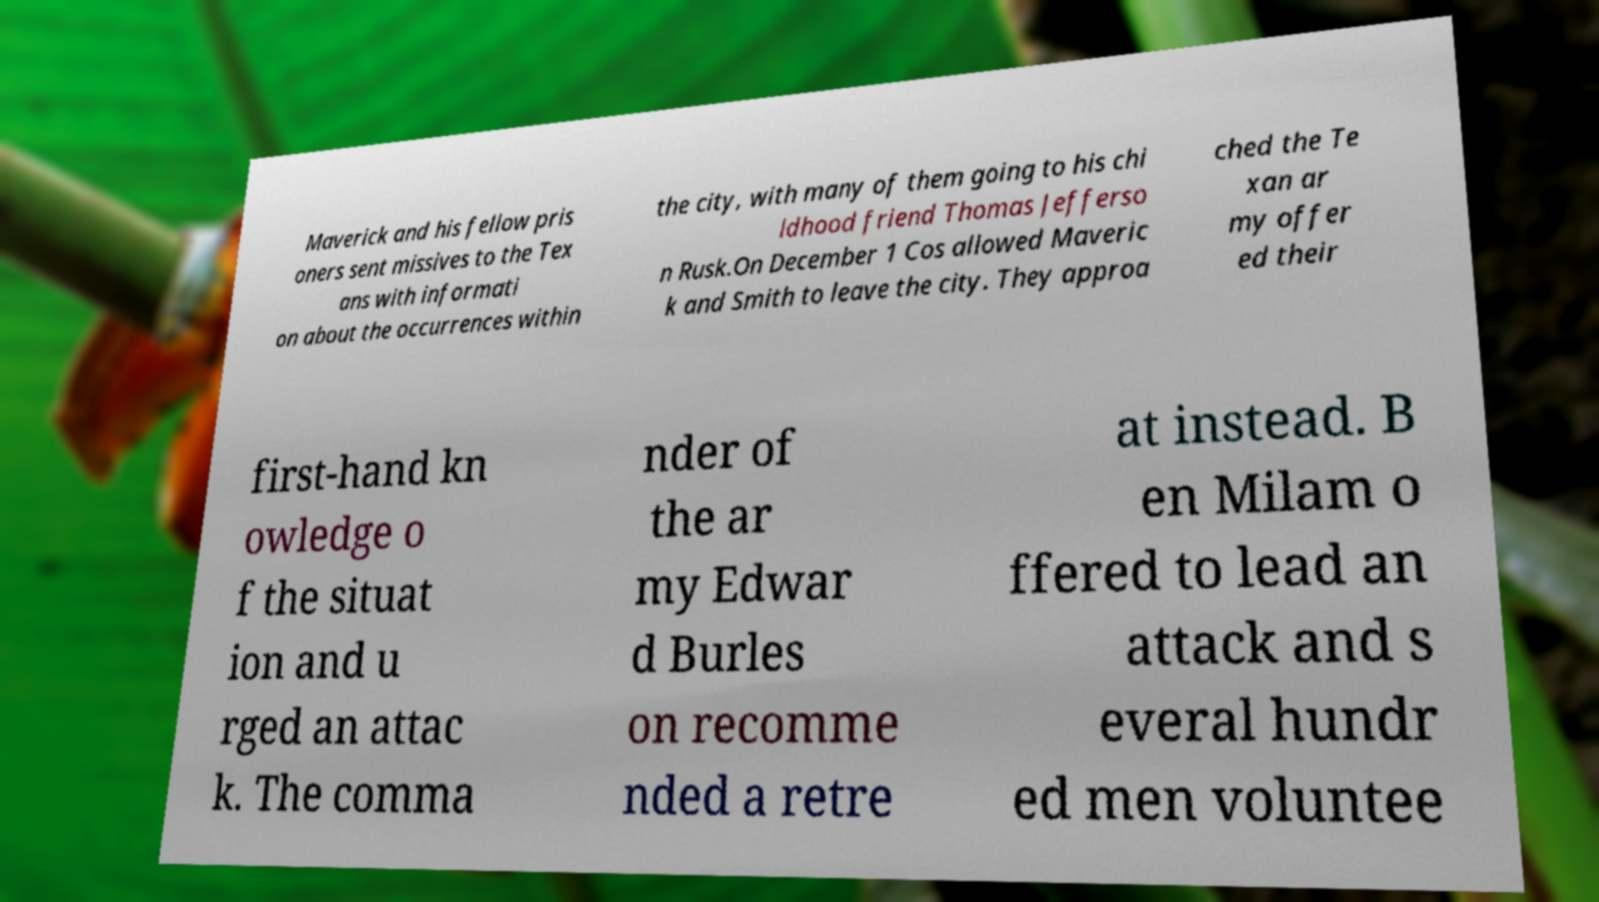Could you extract and type out the text from this image? Maverick and his fellow pris oners sent missives to the Tex ans with informati on about the occurrences within the city, with many of them going to his chi ldhood friend Thomas Jefferso n Rusk.On December 1 Cos allowed Maveric k and Smith to leave the city. They approa ched the Te xan ar my offer ed their first-hand kn owledge o f the situat ion and u rged an attac k. The comma nder of the ar my Edwar d Burles on recomme nded a retre at instead. B en Milam o ffered to lead an attack and s everal hundr ed men voluntee 